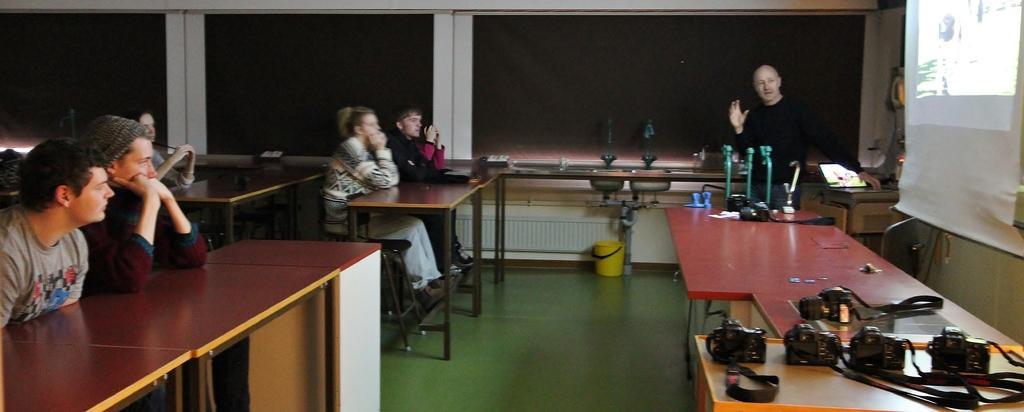Could you give a brief overview of what you see in this image? In this picture there is a table on the right side of the image, on which there are cameras and there is a projector screen and a man on the right side of the image, he is explaining, there are people those who are sitting on the benches on the left side of the image and there is a bucket on the floor in the center of the image. 